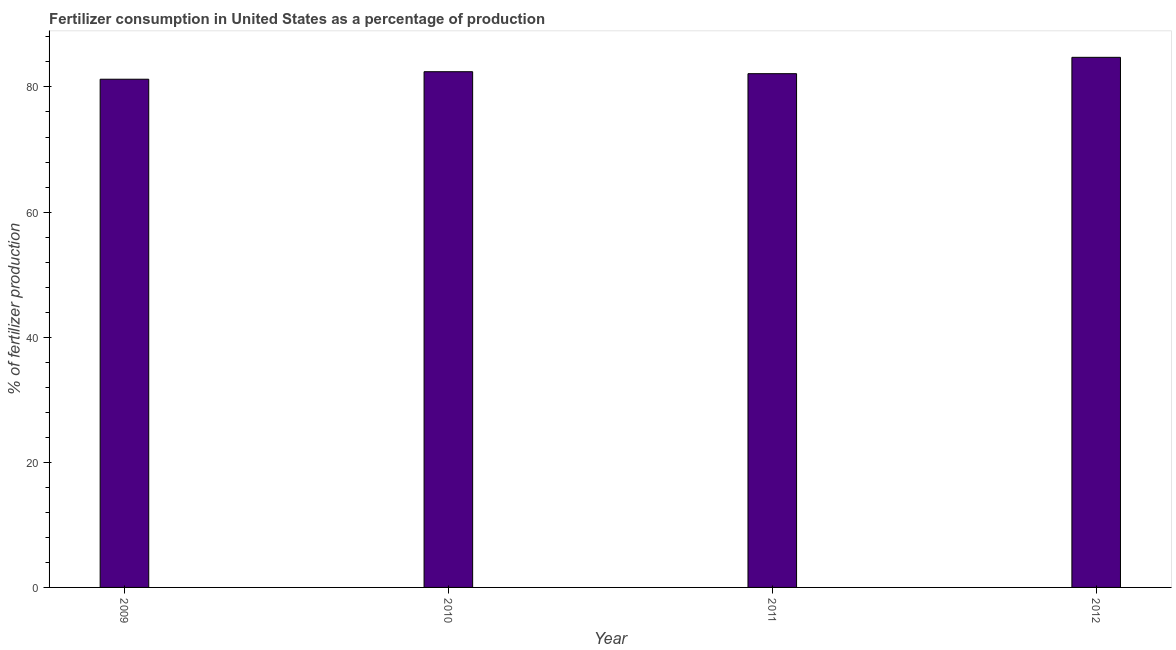What is the title of the graph?
Offer a terse response. Fertilizer consumption in United States as a percentage of production. What is the label or title of the Y-axis?
Keep it short and to the point. % of fertilizer production. What is the amount of fertilizer consumption in 2012?
Your answer should be compact. 84.74. Across all years, what is the maximum amount of fertilizer consumption?
Your answer should be compact. 84.74. Across all years, what is the minimum amount of fertilizer consumption?
Keep it short and to the point. 81.24. In which year was the amount of fertilizer consumption minimum?
Offer a very short reply. 2009. What is the sum of the amount of fertilizer consumption?
Provide a succinct answer. 330.54. What is the difference between the amount of fertilizer consumption in 2011 and 2012?
Offer a terse response. -2.61. What is the average amount of fertilizer consumption per year?
Offer a terse response. 82.63. What is the median amount of fertilizer consumption?
Offer a terse response. 82.28. In how many years, is the amount of fertilizer consumption greater than 24 %?
Your response must be concise. 4. What is the difference between the highest and the second highest amount of fertilizer consumption?
Offer a terse response. 2.3. What is the difference between the highest and the lowest amount of fertilizer consumption?
Your response must be concise. 3.5. In how many years, is the amount of fertilizer consumption greater than the average amount of fertilizer consumption taken over all years?
Your response must be concise. 1. How many bars are there?
Keep it short and to the point. 4. Are all the bars in the graph horizontal?
Your response must be concise. No. What is the difference between two consecutive major ticks on the Y-axis?
Make the answer very short. 20. What is the % of fertilizer production of 2009?
Make the answer very short. 81.24. What is the % of fertilizer production in 2010?
Your answer should be compact. 82.44. What is the % of fertilizer production of 2011?
Your answer should be very brief. 82.12. What is the % of fertilizer production of 2012?
Make the answer very short. 84.74. What is the difference between the % of fertilizer production in 2009 and 2010?
Provide a succinct answer. -1.2. What is the difference between the % of fertilizer production in 2009 and 2011?
Keep it short and to the point. -0.88. What is the difference between the % of fertilizer production in 2009 and 2012?
Provide a short and direct response. -3.5. What is the difference between the % of fertilizer production in 2010 and 2011?
Offer a very short reply. 0.32. What is the difference between the % of fertilizer production in 2010 and 2012?
Your response must be concise. -2.3. What is the difference between the % of fertilizer production in 2011 and 2012?
Make the answer very short. -2.61. What is the ratio of the % of fertilizer production in 2009 to that in 2012?
Your answer should be very brief. 0.96. What is the ratio of the % of fertilizer production in 2010 to that in 2011?
Your response must be concise. 1. 